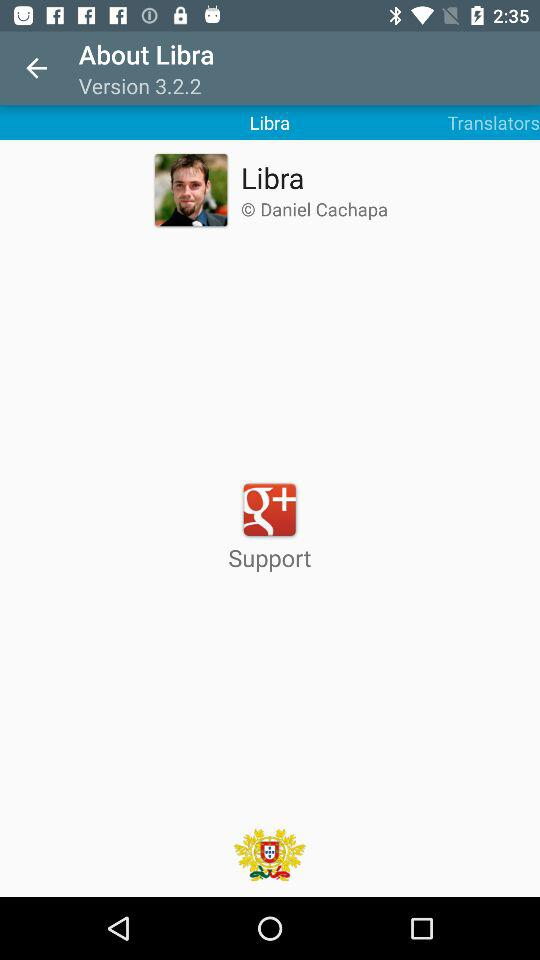What is the version? The version is 3.2.2. 